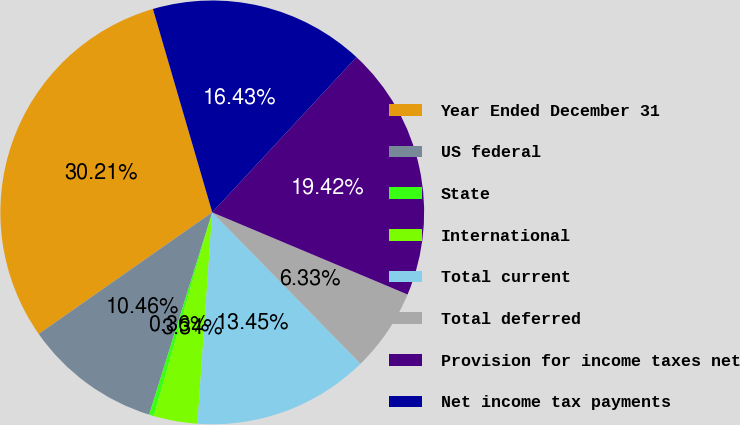<chart> <loc_0><loc_0><loc_500><loc_500><pie_chart><fcel>Year Ended December 31<fcel>US federal<fcel>State<fcel>International<fcel>Total current<fcel>Total deferred<fcel>Provision for income taxes net<fcel>Net income tax payments<nl><fcel>30.21%<fcel>10.46%<fcel>0.36%<fcel>3.34%<fcel>13.45%<fcel>6.33%<fcel>19.42%<fcel>16.43%<nl></chart> 